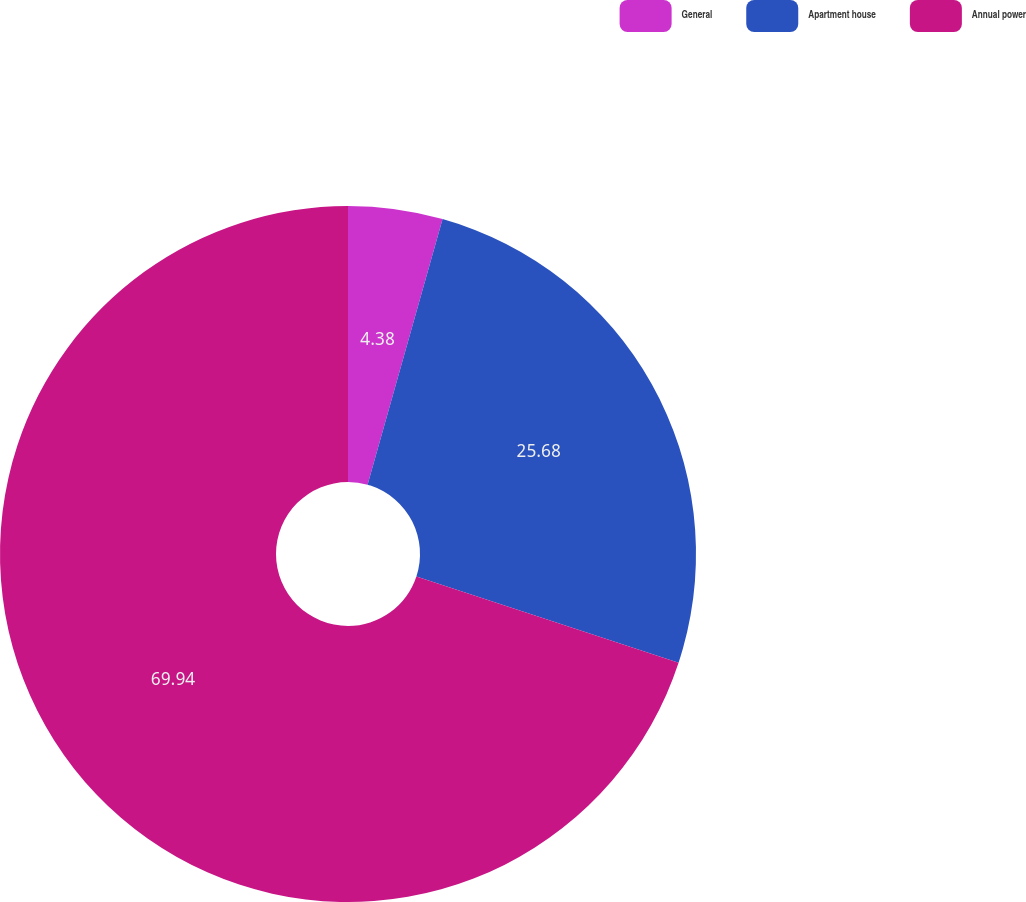<chart> <loc_0><loc_0><loc_500><loc_500><pie_chart><fcel>General<fcel>Apartment house<fcel>Annual power<nl><fcel>4.38%<fcel>25.68%<fcel>69.94%<nl></chart> 